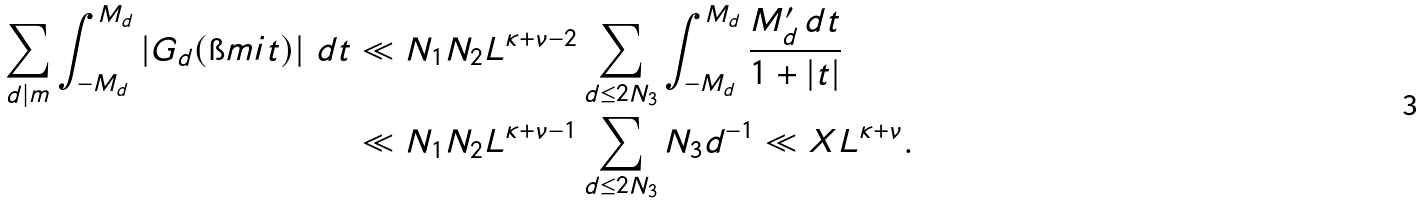Convert formula to latex. <formula><loc_0><loc_0><loc_500><loc_500>\sum _ { d | m } \int _ { - M _ { d } } ^ { M _ { d } } \left | G _ { d } ( \i m i t ) \right | \, d t & \ll N _ { 1 } N _ { 2 } L ^ { \kappa + \nu - 2 } \sum _ { d \leq 2 N _ { 3 } } \int _ { - M _ { d } } ^ { M _ { d } } \frac { M _ { d } ^ { \prime } \, d t } { 1 + | t | } \\ & \ll N _ { 1 } N _ { 2 } L ^ { \kappa + \nu - 1 } \sum _ { d \leq 2 N _ { 3 } } N _ { 3 } d ^ { - 1 } \ll X L ^ { \kappa + \nu } .</formula> 